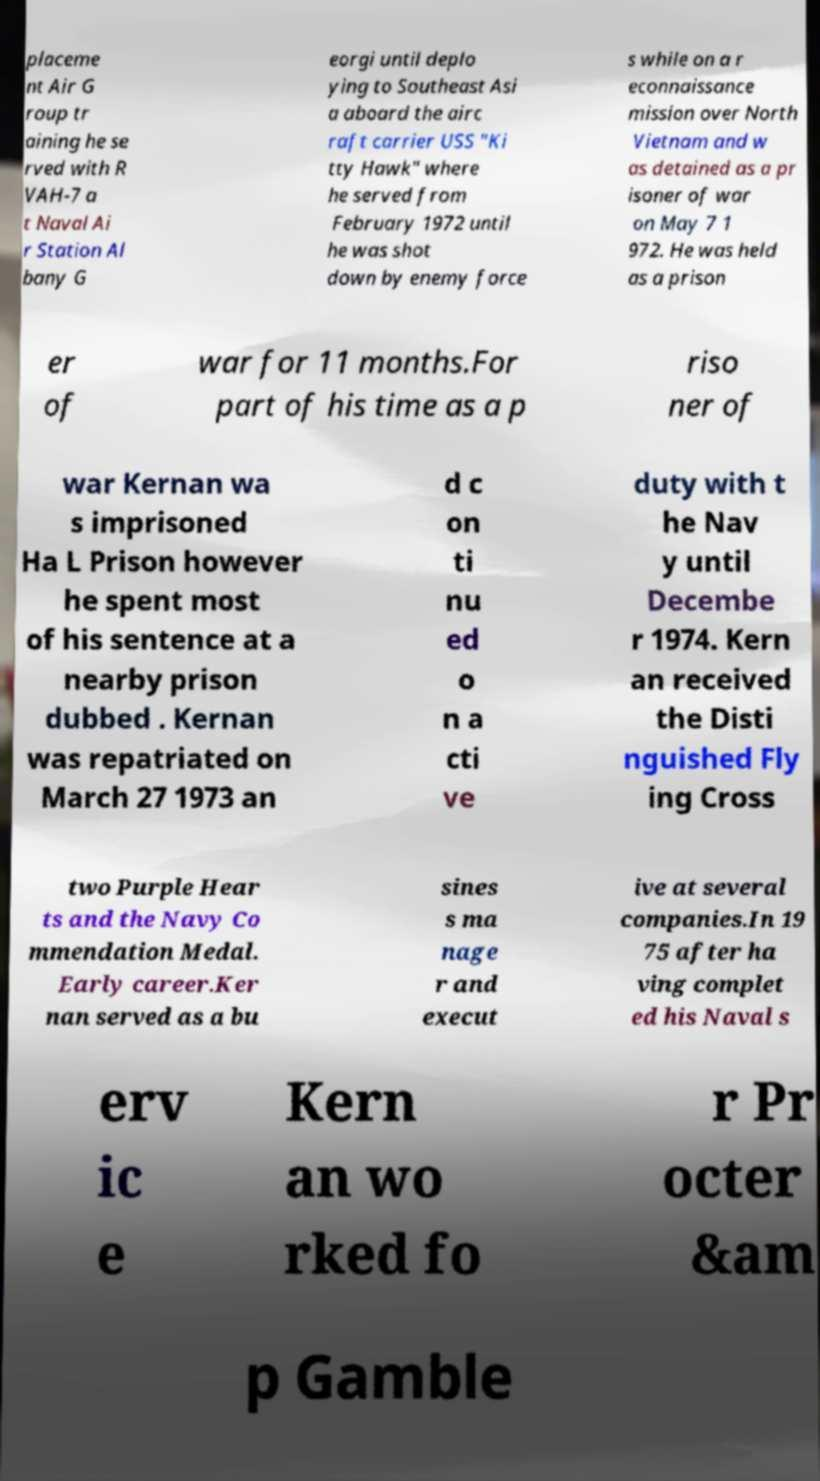There's text embedded in this image that I need extracted. Can you transcribe it verbatim? placeme nt Air G roup tr aining he se rved with R VAH-7 a t Naval Ai r Station Al bany G eorgi until deplo ying to Southeast Asi a aboard the airc raft carrier USS "Ki tty Hawk" where he served from February 1972 until he was shot down by enemy force s while on a r econnaissance mission over North Vietnam and w as detained as a pr isoner of war on May 7 1 972. He was held as a prison er of war for 11 months.For part of his time as a p riso ner of war Kernan wa s imprisoned Ha L Prison however he spent most of his sentence at a nearby prison dubbed . Kernan was repatriated on March 27 1973 an d c on ti nu ed o n a cti ve duty with t he Nav y until Decembe r 1974. Kern an received the Disti nguished Fly ing Cross two Purple Hear ts and the Navy Co mmendation Medal. Early career.Ker nan served as a bu sines s ma nage r and execut ive at several companies.In 19 75 after ha ving complet ed his Naval s erv ic e Kern an wo rked fo r Pr octer &am p Gamble 